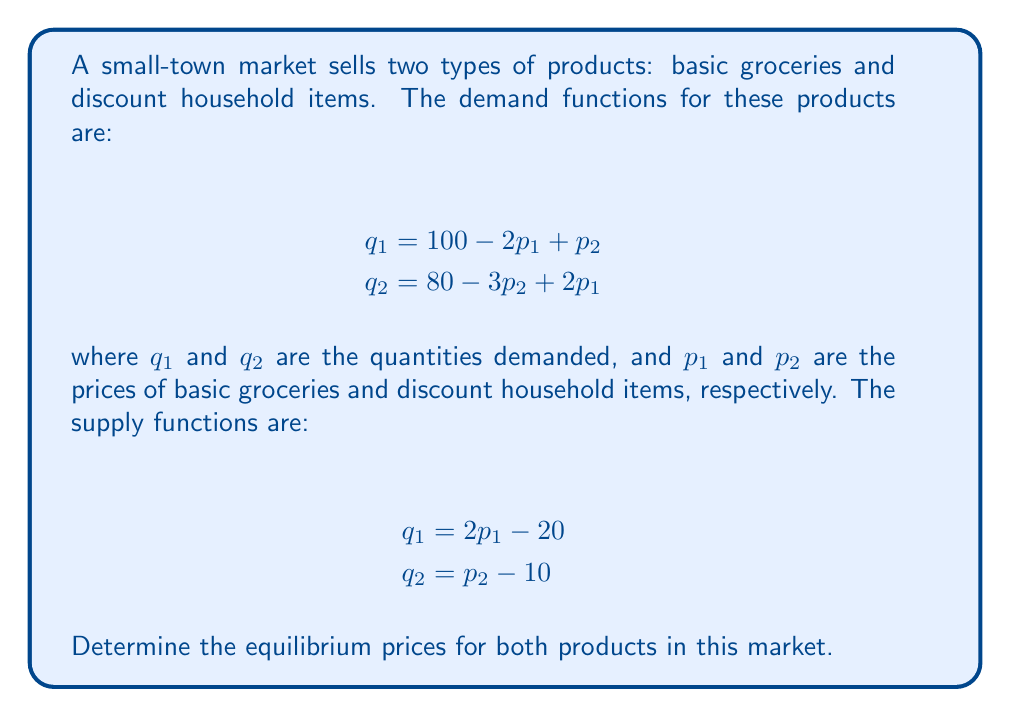Show me your answer to this math problem. Let's solve this step-by-step:

1) In equilibrium, supply equals demand for each product. So we can set up two equations:

   For basic groceries: $100 - 2p_1 + p_2 = 2p_1 - 20$
   For discount items: $80 - 3p_2 + 2p_1 = p_2 - 10$

2) Simplify the first equation:
   $100 - 2p_1 + p_2 = 2p_1 - 20$
   $120 + p_2 = 4p_1$
   $p_2 = 4p_1 - 120$ ... (Equation 1)

3) Substitute this into the second equation:
   $80 - 3(4p_1 - 120) + 2p_1 = (4p_1 - 120) - 10$
   $80 - 12p_1 + 360 + 2p_1 = 4p_1 - 130$
   $440 - 10p_1 = 4p_1 - 130$
   $570 = 14p_1$
   $p_1 = 40.71$ (rounded to 2 decimal places)

4) Substitute this back into Equation 1:
   $p_2 = 4(40.71) - 120$
   $p_2 = 42.84$

5) Therefore, the equilibrium prices are:
   $p_1 = 40.71$ for basic groceries
   $p_2 = 42.84$ for discount household items
Answer: $p_1 = 40.71$, $p_2 = 42.84$ 